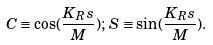Convert formula to latex. <formula><loc_0><loc_0><loc_500><loc_500>C \equiv \cos ( \frac { K _ { R } s } { M } ) ; \, S \equiv \sin ( \frac { K _ { R } s } { M } ) .</formula> 